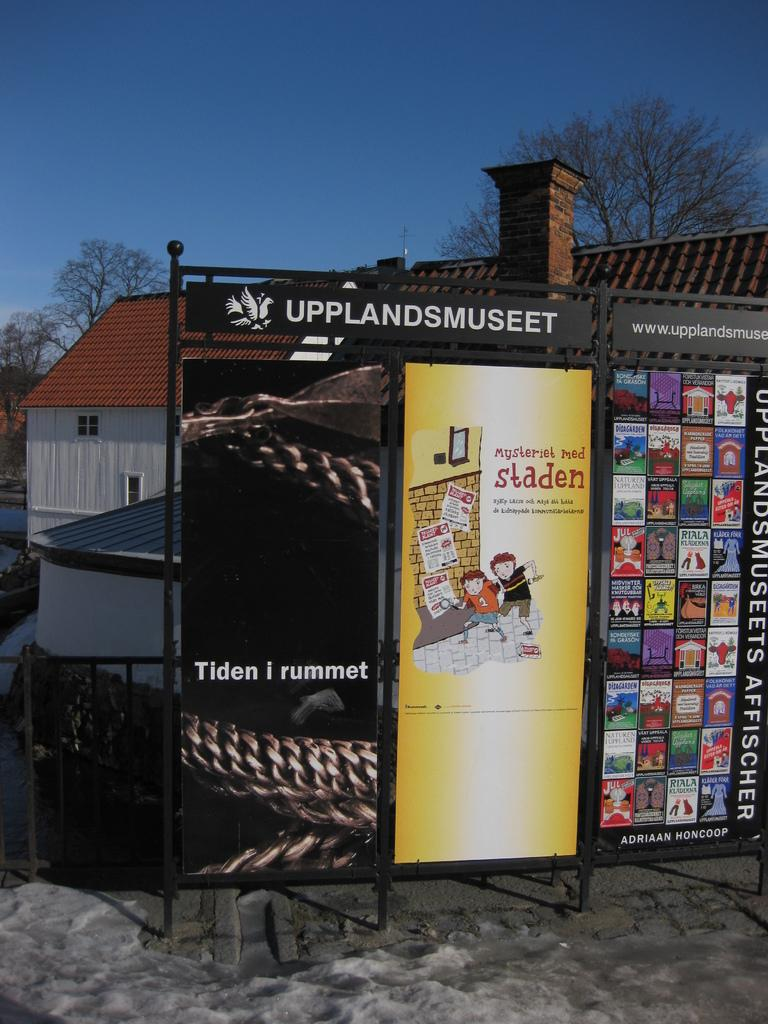<image>
Describe the image concisely. A stand up metal piece with advertisement for Uppland Museet which shows different covers. 